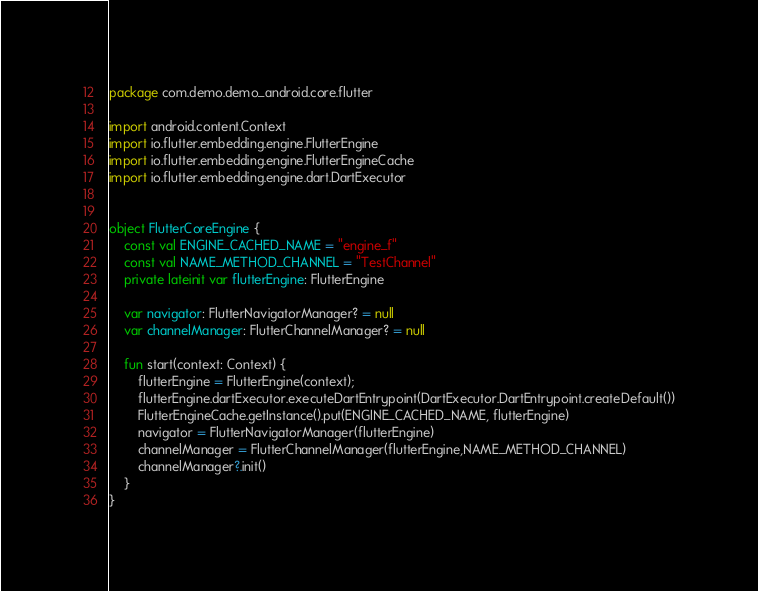<code> <loc_0><loc_0><loc_500><loc_500><_Kotlin_>package com.demo.demo_android.core.flutter

import android.content.Context
import io.flutter.embedding.engine.FlutterEngine
import io.flutter.embedding.engine.FlutterEngineCache
import io.flutter.embedding.engine.dart.DartExecutor


object FlutterCoreEngine {
    const val ENGINE_CACHED_NAME = "engine_f"
    const val NAME_METHOD_CHANNEL = "TestChannel"
    private lateinit var flutterEngine: FlutterEngine

    var navigator: FlutterNavigatorManager? = null
    var channelManager: FlutterChannelManager? = null

    fun start(context: Context) {
        flutterEngine = FlutterEngine(context);
        flutterEngine.dartExecutor.executeDartEntrypoint(DartExecutor.DartEntrypoint.createDefault())
        FlutterEngineCache.getInstance().put(ENGINE_CACHED_NAME, flutterEngine)
        navigator = FlutterNavigatorManager(flutterEngine)
        channelManager = FlutterChannelManager(flutterEngine,NAME_METHOD_CHANNEL)
        channelManager?.init()
    }
}
</code> 